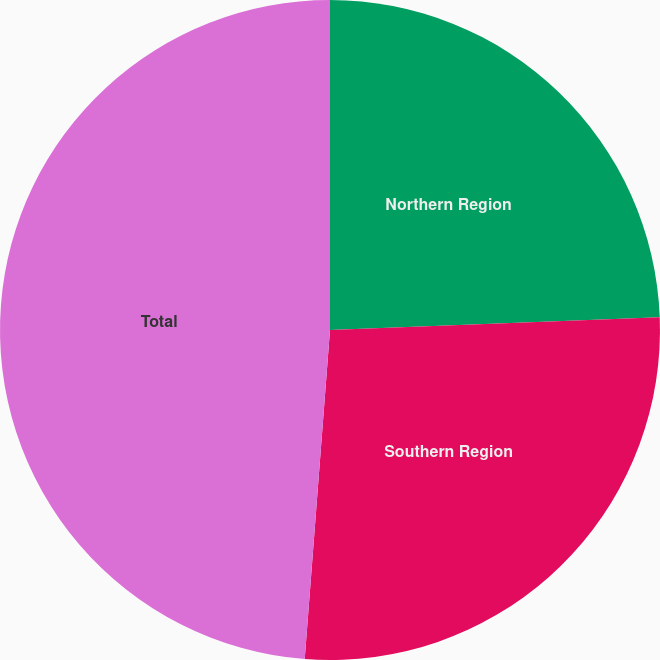Convert chart. <chart><loc_0><loc_0><loc_500><loc_500><pie_chart><fcel>Northern Region<fcel>Southern Region<fcel>Total<nl><fcel>24.39%<fcel>26.83%<fcel>48.78%<nl></chart> 